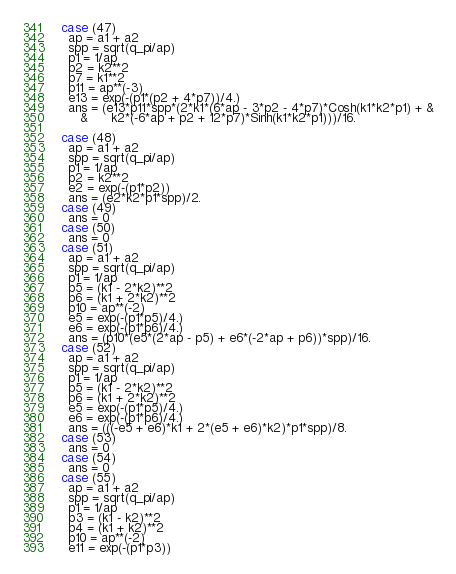<code> <loc_0><loc_0><loc_500><loc_500><_FORTRAN_>  case (47) 
    ap = a1 + a2 
    spp = sqrt(q_pi/ap) 
    p1 = 1/ap
    p2 = k2**2
    p7 = k1**2
    p11 = ap**(-3)
    e13 = exp(-(p1*(p2 + 4*p7))/4.)
    ans = (e13*p11*spp*(2*k1*(6*ap - 3*p2 - 4*p7)*Cosh(k1*k2*p1) + &
       &      k2*(-6*ap + p2 + 12*p7)*Sinh(k1*k2*p1)))/16.

  case (48) 
    ap = a1 + a2 
    spp = sqrt(q_pi/ap) 
    p1 = 1/ap
    p2 = k2**2
    e2 = exp(-(p1*p2))
    ans = (e2*k2*p1*spp)/2.
  case (49) 
    ans = 0
  case (50) 
    ans = 0
  case (51) 
    ap = a1 + a2 
    spp = sqrt(q_pi/ap) 
    p1 = 1/ap
    p5 = (k1 - 2*k2)**2
    p6 = (k1 + 2*k2)**2
    p10 = ap**(-2)
    e5 = exp(-(p1*p5)/4.)
    e6 = exp(-(p1*p6)/4.)
    ans = (p10*(e5*(2*ap - p5) + e6*(-2*ap + p6))*spp)/16.
  case (52) 
    ap = a1 + a2 
    spp = sqrt(q_pi/ap) 
    p1 = 1/ap
    p5 = (k1 - 2*k2)**2
    p6 = (k1 + 2*k2)**2
    e5 = exp(-(p1*p5)/4.)
    e6 = exp(-(p1*p6)/4.)
    ans = (((-e5 + e6)*k1 + 2*(e5 + e6)*k2)*p1*spp)/8.
  case (53) 
    ans = 0
  case (54) 
    ans = 0
  case (55) 
    ap = a1 + a2 
    spp = sqrt(q_pi/ap) 
    p1 = 1/ap
    p3 = (k1 - k2)**2
    p4 = (k1 + k2)**2
    p10 = ap**(-2)
    e11 = exp(-(p1*p3))</code> 